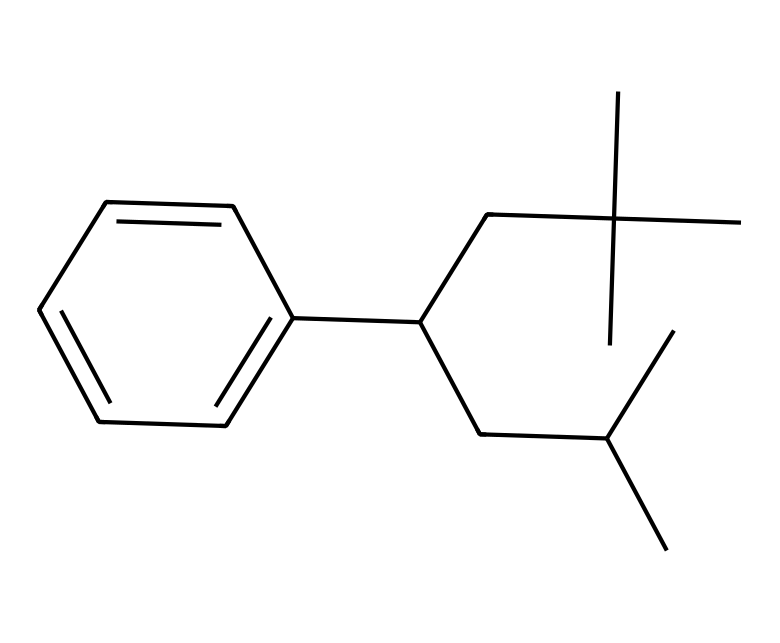What is the molecular formula of polystyrene based on the SMILES representation? To determine the molecular formula from the SMILES, we identify the atoms present in the structure. The structure features carbon (C) and hydrogen (H) atoms. Counting the number of carbon and hydrogen atoms gives us C18H30.
Answer: C18H30 How many benzene rings are present in the polystyrene structure? Looking at the structure, we can identify that there is one benzene ring (c1ccccc1), which constitutes the phenyl group part of polystyrene.
Answer: 1 What is the degree of branching in polystyrene as indicated by the structure? The SMILES shows that the carbon atoms have branched structures (CC(C)(C)), indicating multiple branching points. This suggests that polystyrene is a branched polymer.
Answer: branched What type of polymerization leads to the formation of polystyrene as represented in this structure? The presence of a benzene ring along with the carbon backbone indicates that the polymer is formed through chain-growth polymerization, specifically by the polymerization of styrene monomers.
Answer: chain-growth What specific properties influence the use of polystyrene in disposable food containers? Polystyrene is lightweight, has good insulation properties, and is resistant to moisture and chemicals, making it suitable for disposable food containers.
Answer: lightweight, insulation, moisture-resistant What conformation does polystyrene likely adopt in its physical state based on this representation? The structure's branched and aromatic nature suggests that polystyrene may adopt a glassy or amorphous state, which contributes to its rigidity and shape-retention in food containers.
Answer: glassy or amorphous 